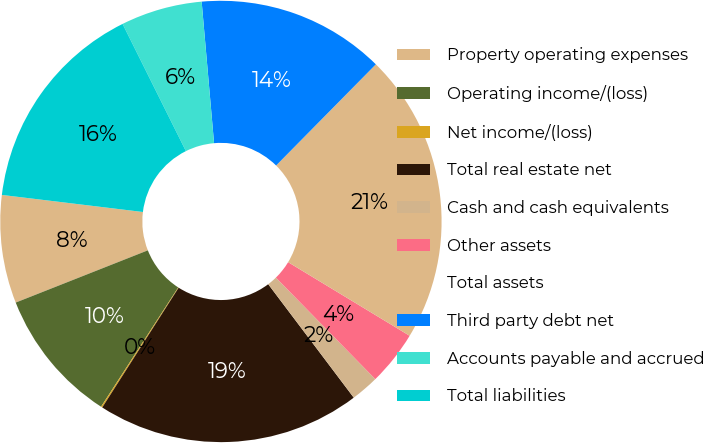Convert chart. <chart><loc_0><loc_0><loc_500><loc_500><pie_chart><fcel>Property operating expenses<fcel>Operating income/(loss)<fcel>Net income/(loss)<fcel>Total real estate net<fcel>Cash and cash equivalents<fcel>Other assets<fcel>Total assets<fcel>Third party debt net<fcel>Accounts payable and accrued<fcel>Total liabilities<nl><fcel>7.91%<fcel>9.87%<fcel>0.1%<fcel>19.32%<fcel>2.05%<fcel>4.0%<fcel>21.28%<fcel>13.78%<fcel>5.96%<fcel>15.73%<nl></chart> 